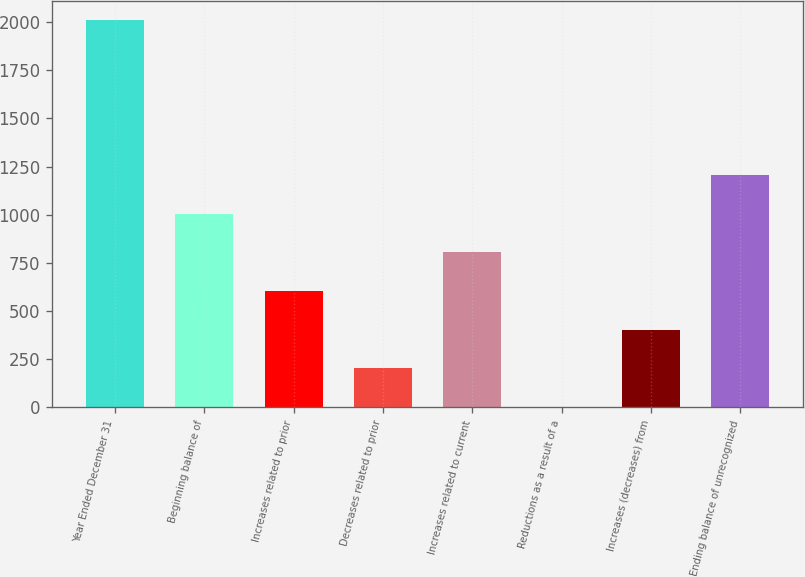Convert chart to OTSL. <chart><loc_0><loc_0><loc_500><loc_500><bar_chart><fcel>Year Ended December 31<fcel>Beginning balance of<fcel>Increases related to prior<fcel>Decreases related to prior<fcel>Increases related to current<fcel>Reductions as a result of a<fcel>Increases (decreases) from<fcel>Ending balance of unrecognized<nl><fcel>2010<fcel>1005.5<fcel>603.7<fcel>201.9<fcel>804.6<fcel>1<fcel>402.8<fcel>1206.4<nl></chart> 